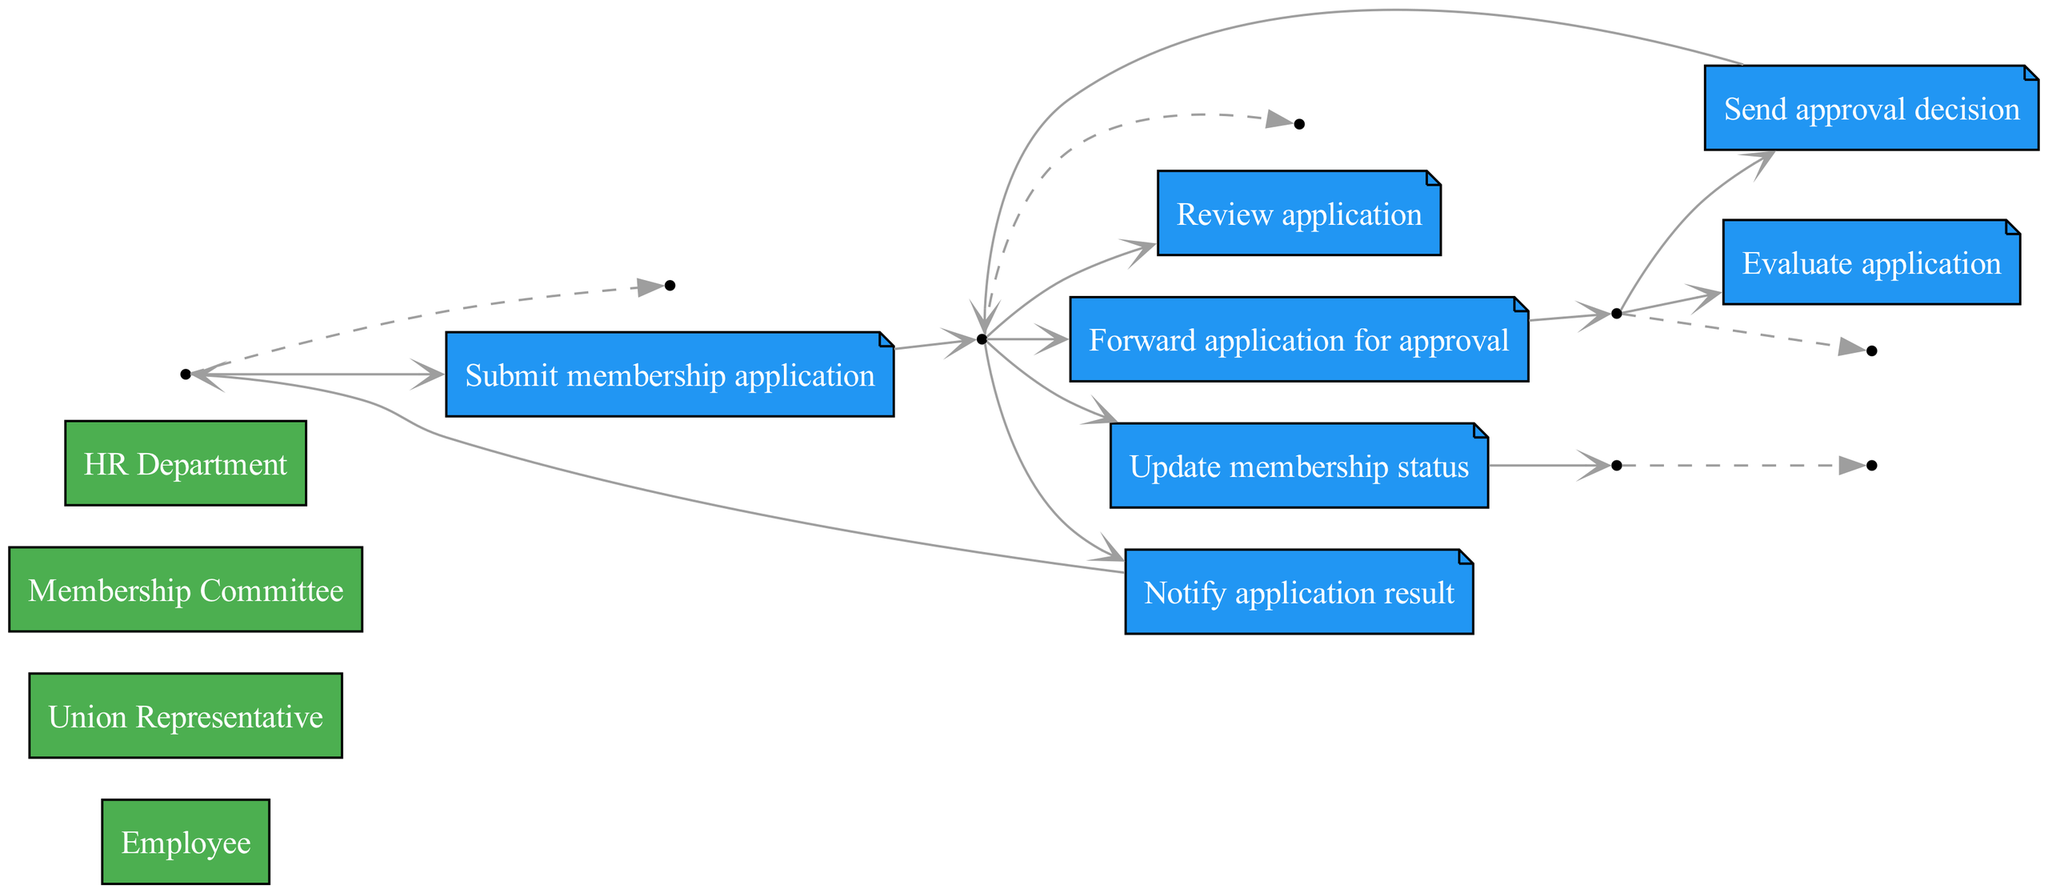What is the first action in the sequence? The first action in the sequence is when the Employee submits a membership application to the Union Representative.
Answer: Submit membership application Who reviews the application? The application is reviewed by the Union Representative before being forwarded for approval.
Answer: Union Representative How many actors are involved in the workflow? There are four distinct actors involved in the membership application and approval workflow, as listed in the diagram.
Answer: Four What does the Membership Committee do after they evaluate the application? After evaluating the application, the Membership Committee sends the approval decision back to the Union Representative.
Answer: Send approval decision Which actor notifies the employee of the application result? The Union Representative is responsible for notifying the Employee about the application result once it is decided.
Answer: Union Representative What is the last action in this sequence? The last action in the sequence is when the Union Representative updates the membership status with the HR Department after the decision is made.
Answer: Update membership status Which two actors are connected directly by the action of forwarding the application? The action of forwarding the application is directly connecting the Union Representative to the Membership Committee.
Answer: Union Representative and Membership Committee What action follows immediately after sending the approval decision? The action that follows immediately after sending the approval decision is the Union Representative notifying the Employee of the application result.
Answer: Notify application result 